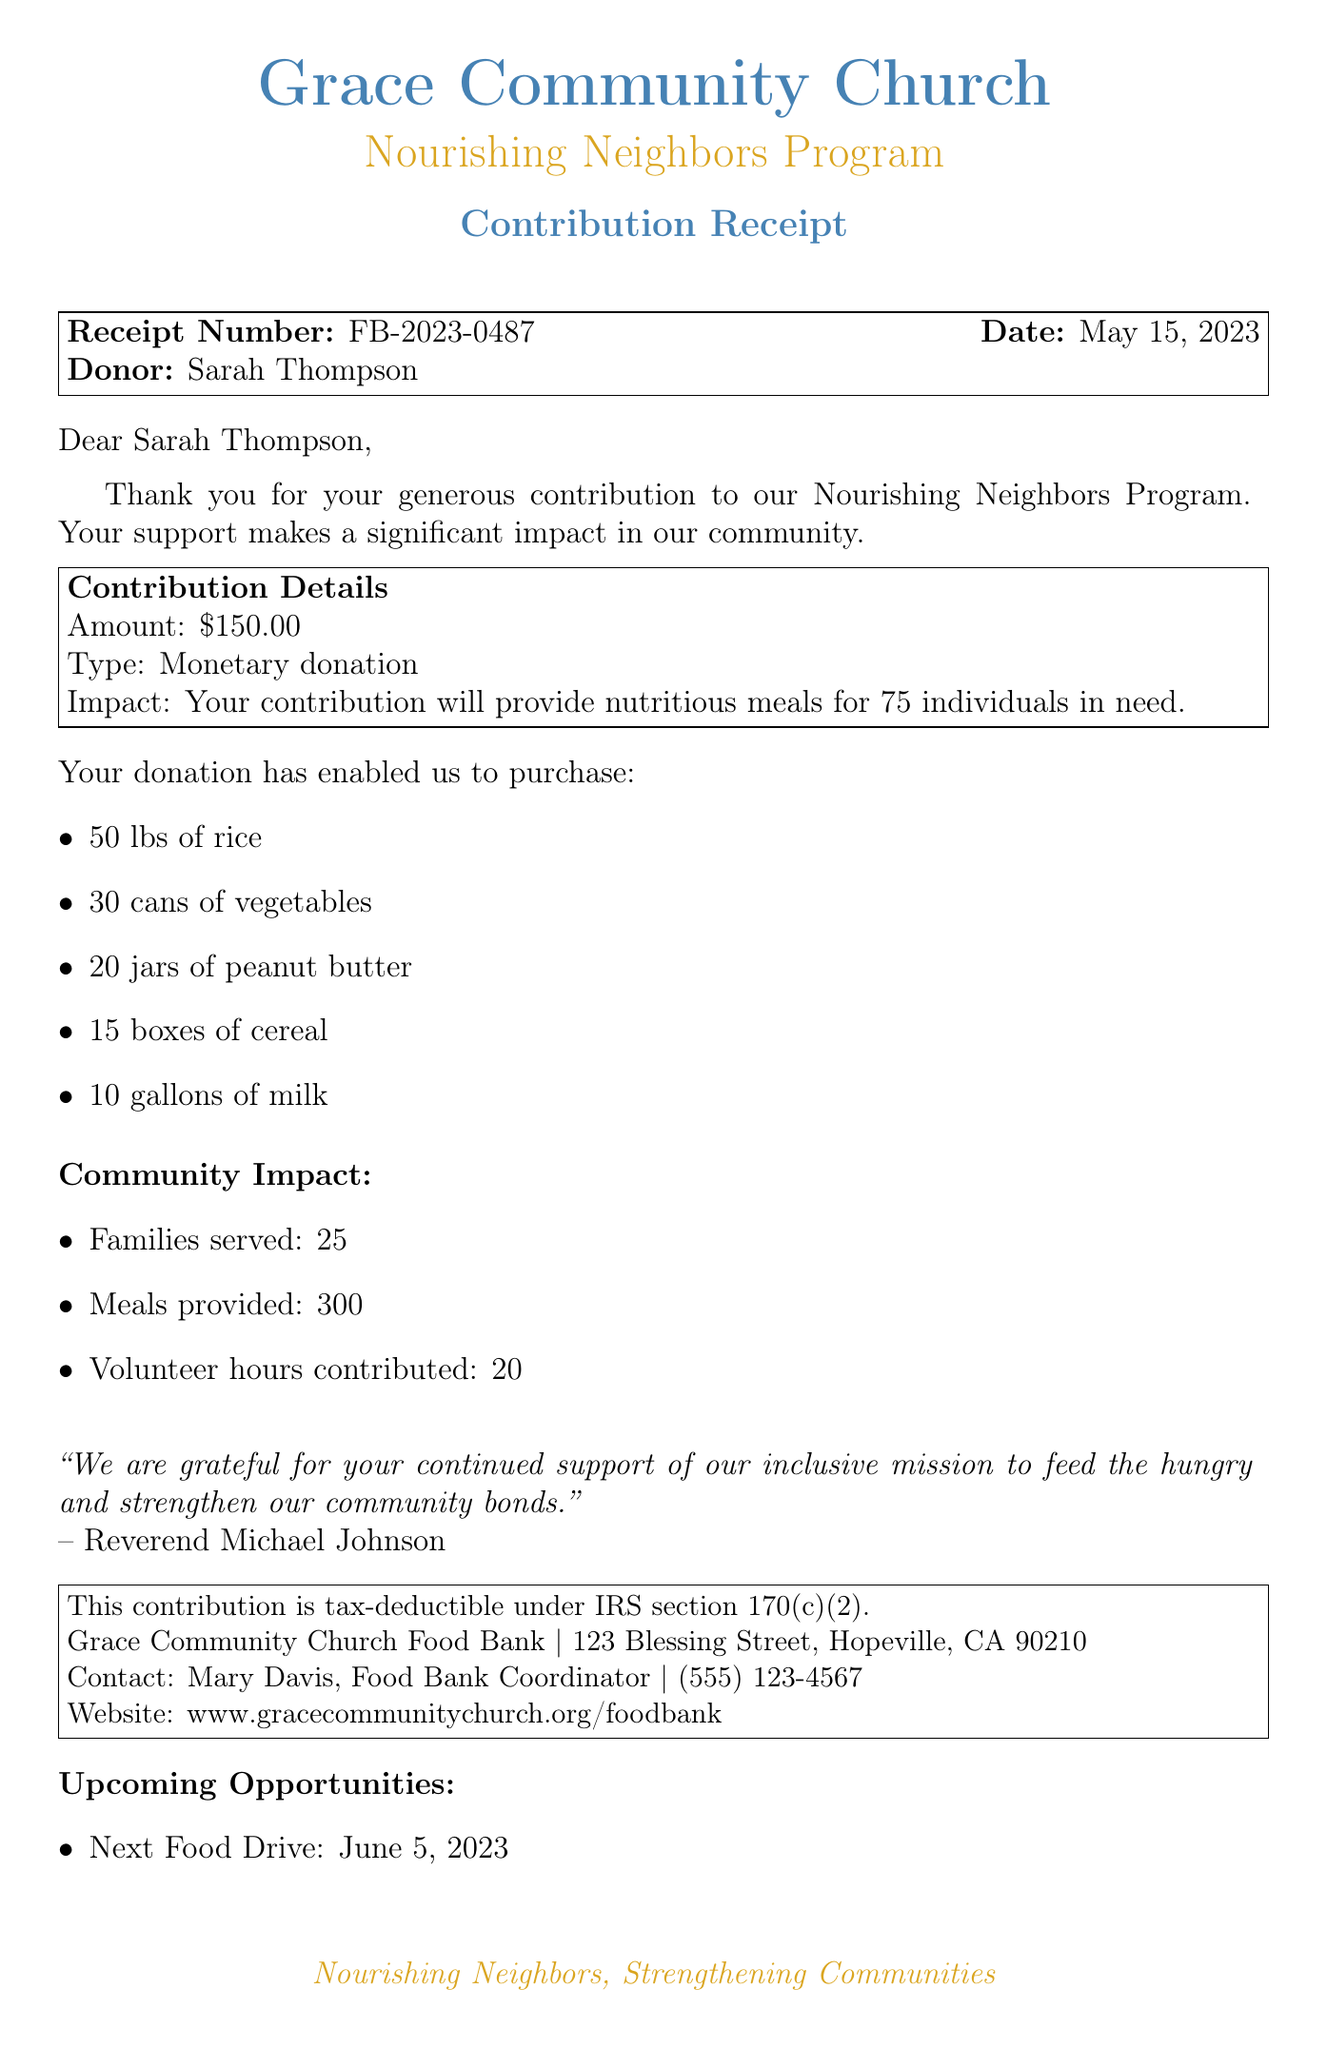What is the contribution amount? The contribution amount can be found in the Contribution Details section of the receipt, which states $150.00.
Answer: $150.00 Who is the donor? The name of the donor is mentioned at the beginning of the receipt, which is Sarah Thompson.
Answer: Sarah Thompson What program is the contribution supporting? The program supported by the contribution is specified as the Nourishing Neighbors Program in the document.
Answer: Nourishing Neighbors Program How many families were served? The number of families served is provided in the Community Impact section, stating 25 families served.
Answer: 25 Who is the contact person for the food bank? The contact person and their role is given towards the end of the receipt, which is Mary Davis, Food Bank Coordinator.
Answer: Mary Davis, Food Bank Coordinator What message did the pastor include? The pastor's message is included in a quote at the bottom of the document, showing appreciation for continued support.
Answer: We are grateful for your continued support of our inclusive mission to feed the hungry and strengthen our community bonds How many meals were provided through the contribution? The total meals provided are mentioned under Community Impact, stating 300 meals were provided.
Answer: 300 When is the next food drive? The date for the next food drive is included in the Upcoming Opportunities section as June 5, 2023.
Answer: June 5, 2023 